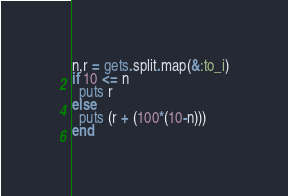Convert code to text. <code><loc_0><loc_0><loc_500><loc_500><_Ruby_>n,r = gets.split.map(&:to_i)
if 10 <= n
  puts r
else
  puts (r + (100*(10-n)))
end</code> 